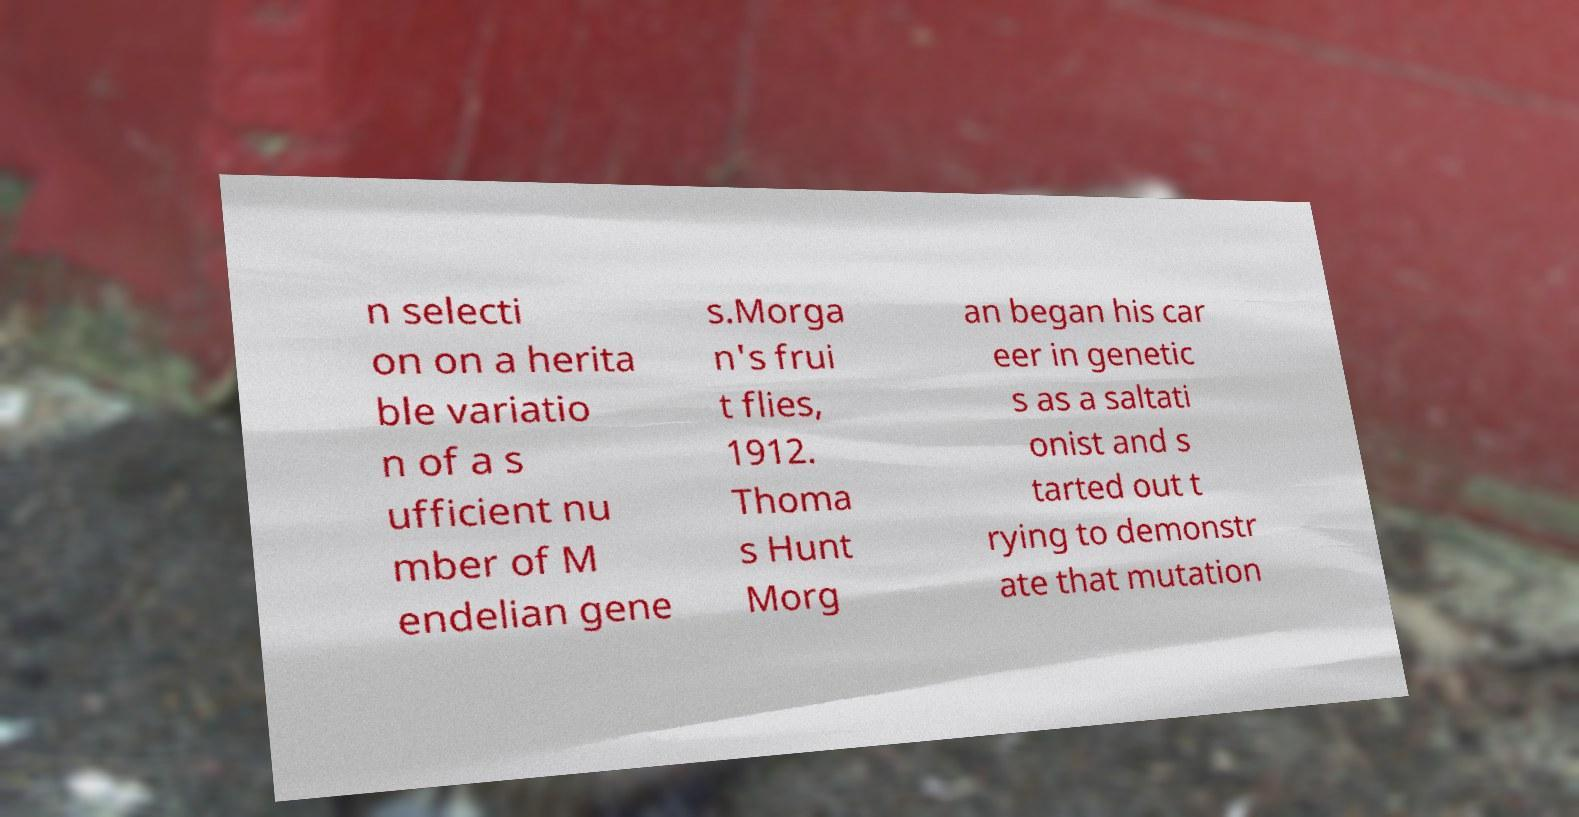Can you read and provide the text displayed in the image?This photo seems to have some interesting text. Can you extract and type it out for me? n selecti on on a herita ble variatio n of a s ufficient nu mber of M endelian gene s.Morga n's frui t flies, 1912. Thoma s Hunt Morg an began his car eer in genetic s as a saltati onist and s tarted out t rying to demonstr ate that mutation 